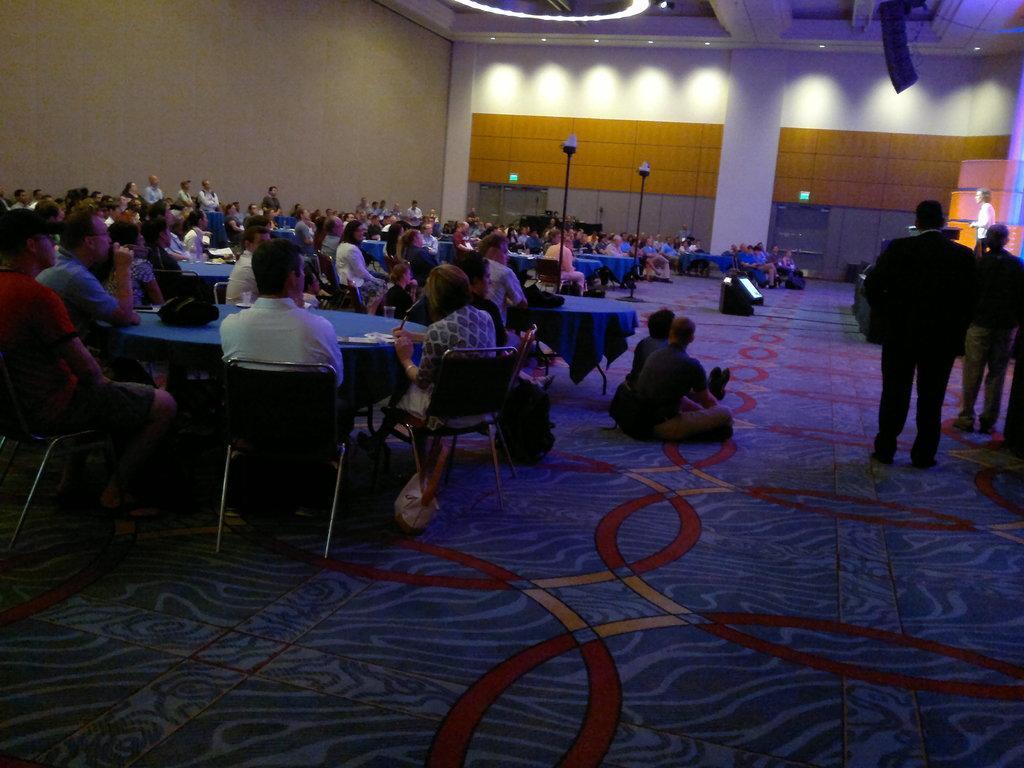In one or two sentences, can you explain what this image depicts? Here there are few people sitting on the chairs at the table. On the table we can see glass,papers and a bag. There are two persons sitting on the carpet on the floor and on the right there are two men standing and a woman is standing on the stage at the podium. In the background on the left there are few persons standing,wall,glass doors,lights on the ceiling,lights on the floor and other objects. 